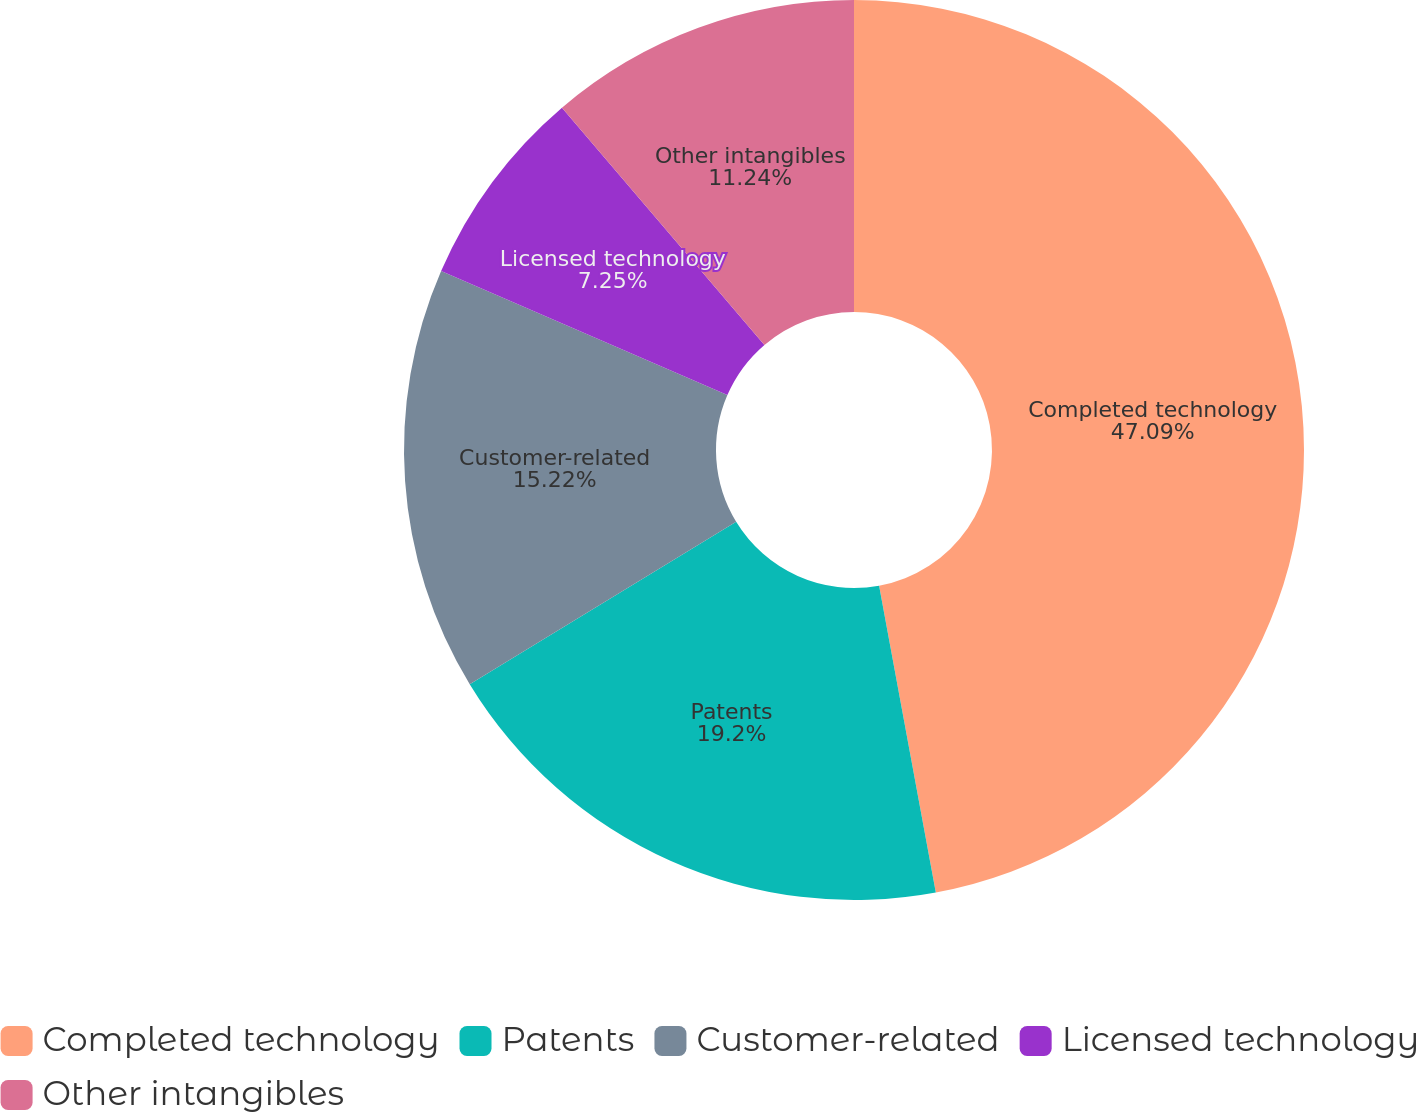Convert chart to OTSL. <chart><loc_0><loc_0><loc_500><loc_500><pie_chart><fcel>Completed technology<fcel>Patents<fcel>Customer-related<fcel>Licensed technology<fcel>Other intangibles<nl><fcel>47.09%<fcel>19.2%<fcel>15.22%<fcel>7.25%<fcel>11.24%<nl></chart> 